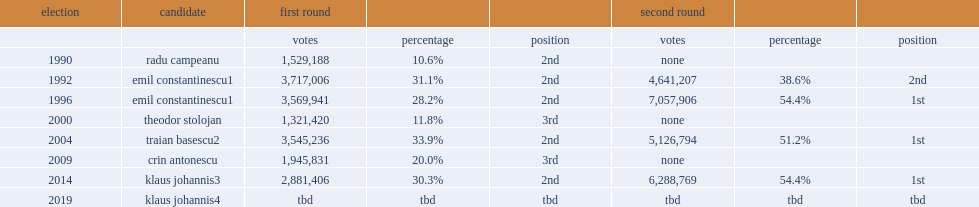How many percent of the vote is belong to radu campeanu? 10.6. 